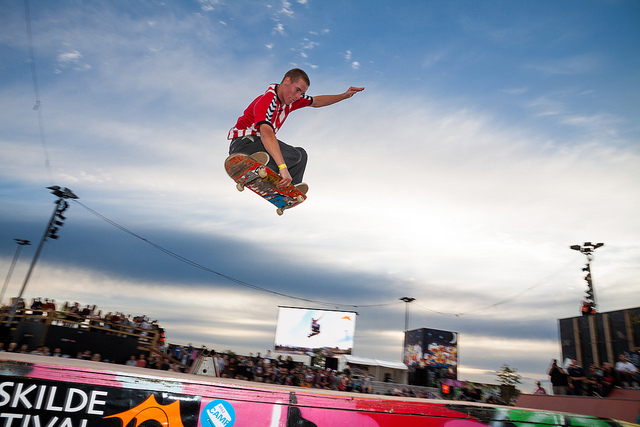What is the name of the trick the man in red is performing?
A. grind
B. manual
C. grab
D. fakie The man in red is performing a trick known as a 'grab.' This term is used to describe a maneuver in skateboarding where the skater jumps and grasps the skateboard with his hand while airborne. Looking at the image, we can clearly see the individual has leapt into the air with a skateboard and is holding onto it with one hand, confirming that it is indeed a grab trick. 